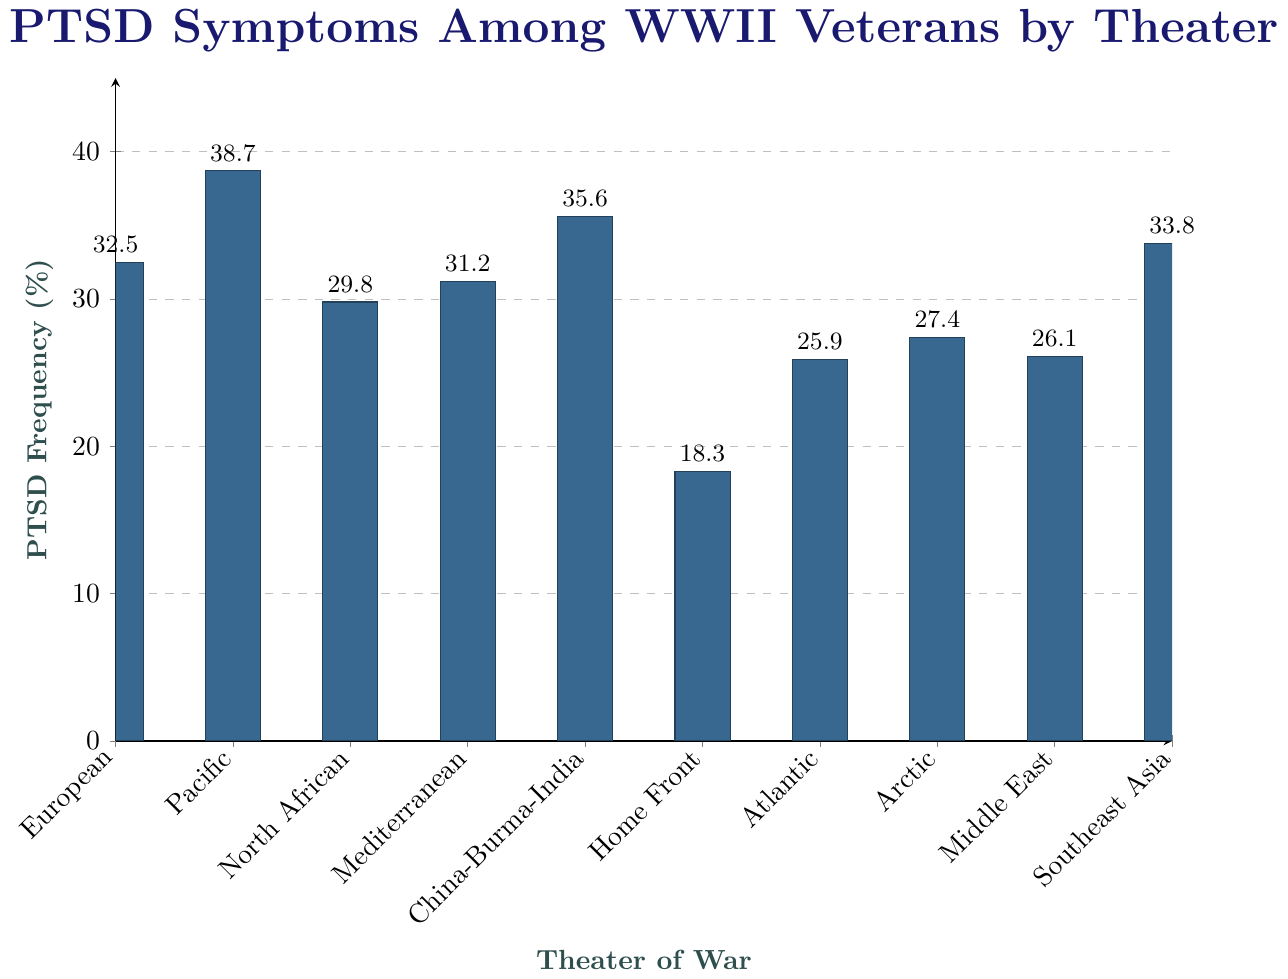Which theater of war has the highest reported PTSD frequency? The vertical bar for the Pacific theater is the tallest, indicating that it has the highest reported PTSD frequency of 38.7%.
Answer: Pacific Which theater of war has the lowest reported PTSD frequency? The vertical bar for the Home Front theater is the shortest, indicating that it has the lowest reported PTSD frequency of 18.3%.
Answer: Home Front How much higher is the PTSD frequency in the Pacific theater compared to the Home Front? The PTSD frequency in the Pacific is 38.7% and in the Home Front is 18.3%. The difference is 38.7% - 18.3% = 20.4%.
Answer: 20.4% What is the average PTSD frequency across all theaters? Add all PTSD frequencies: 32.5 + 38.7 + 29.8 + 31.2 + 35.6 + 18.3 + 25.9 + 27.4 + 26.1 + 33.8 = 299.3, then divide by the number of theaters (10). The average is 299.3 / 10 = 29.93%.
Answer: 29.93% How many theaters have a PTSD frequency greater than 30%? The theaters with PTSD frequencies greater than 30% are European (32.5%), Pacific (38.7%), Mediterranean (31.2%), China-Burma-India (35.6%), and Southeast Asia (33.8%), which makes 5 theaters.
Answer: 5 Which theaters have PTSD frequency within 2% of each other? Comparing each pair, the European (32.5%) and Mediterranean (31.2%) theaters have a difference of 1.3%, which is within 2%.
Answer: European and Mediterranean What is the median PTSD frequency value among the theaters? Order the frequencies: 18.3, 25.9, 26.1, 27.4, 29.8, 31.2, 32.5, 33.8, 35.6, 38.7. The middle value is the average of the 5th and 6th values: (29.8 + 31.2) / 2 = 30.5%.
Answer: 30.5% Does the Atlantic theater have a higher or lower reported PTSD frequency compared to the Arctic theater? The vertical bar for the Atlantic theater is shorter than the bar for the Arctic theater, indicating a lower PTSD frequency of 25.9% compared to 27.4%.
Answer: Lower 